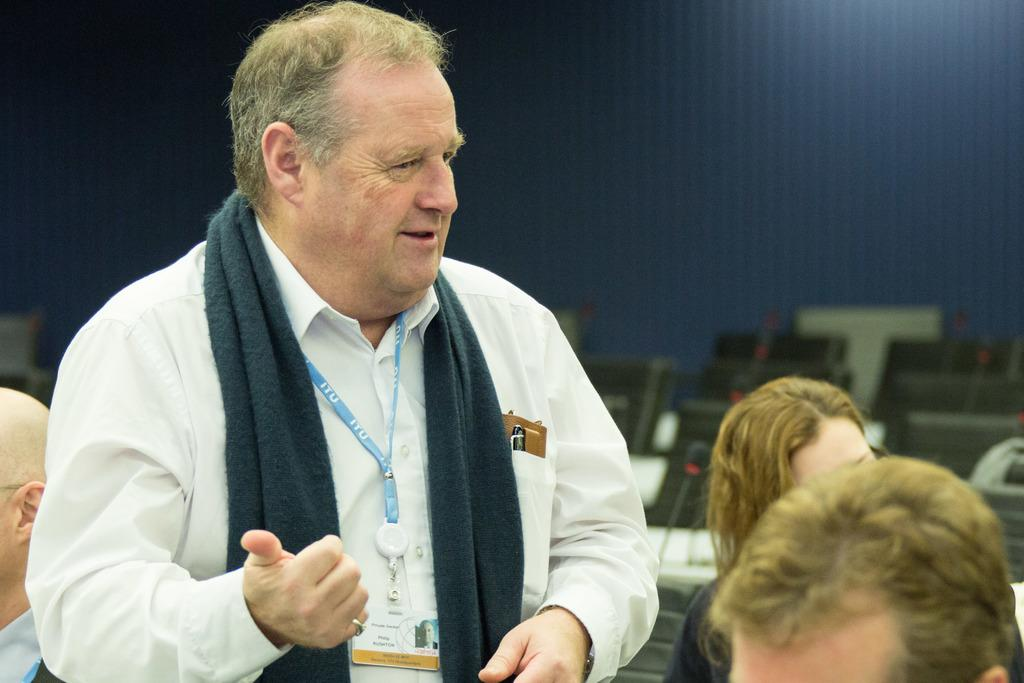How many persons can be seen in the image? There are persons in the image, but the exact number is not specified. What can be seen in the background of the image? There is a wall, chairs, and other objects present in the background of the image. What type of yam is being used to power the machine in the image? There is no yam or machine present in the image. What type of destruction is occurring in the image? There is no destruction present in the image. 